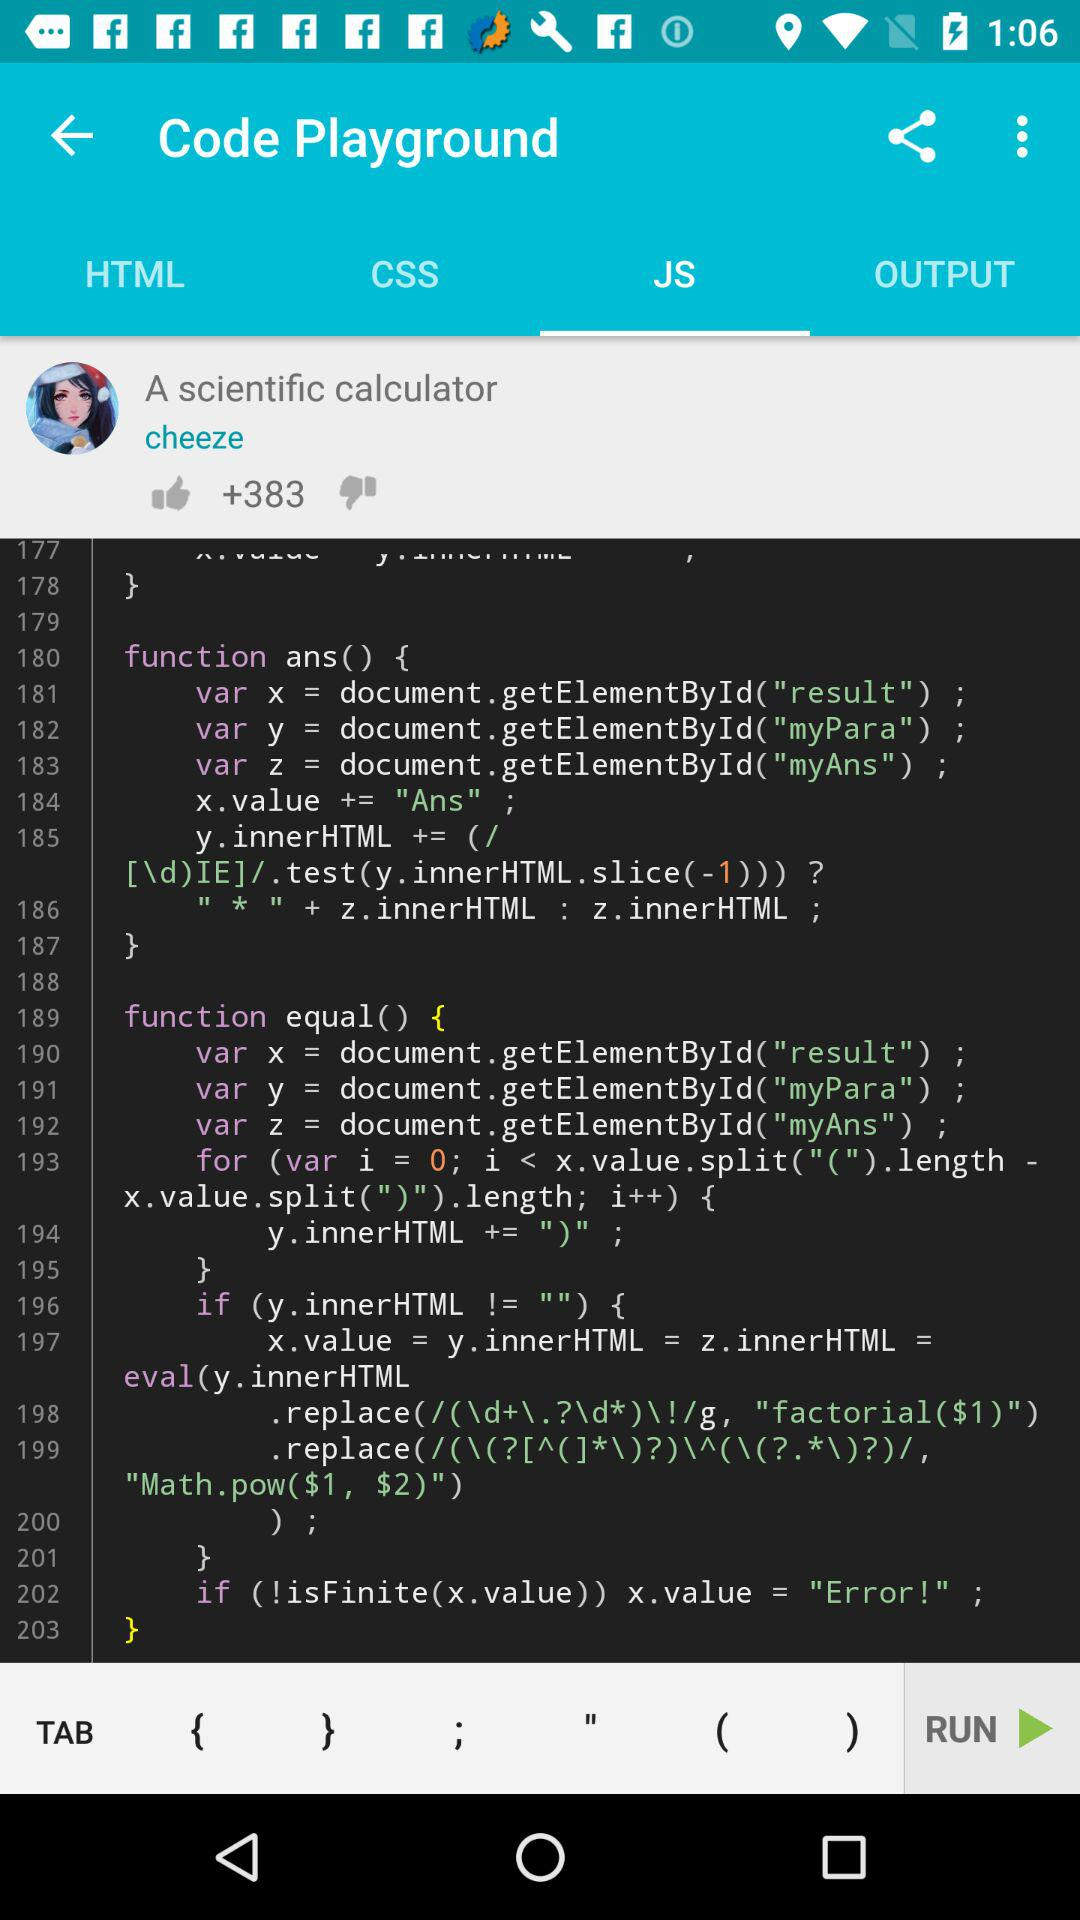Which applications are available for sharing?
When the provided information is insufficient, respond with <no answer>. <no answer> 